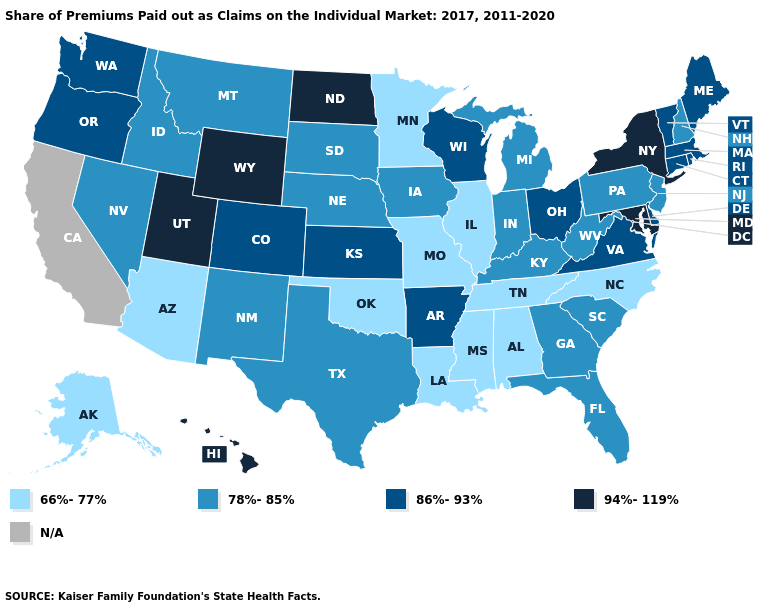Which states have the lowest value in the Northeast?
Concise answer only. New Hampshire, New Jersey, Pennsylvania. What is the value of North Carolina?
Answer briefly. 66%-77%. Does the map have missing data?
Write a very short answer. Yes. What is the highest value in the USA?
Answer briefly. 94%-119%. What is the lowest value in the South?
Write a very short answer. 66%-77%. What is the value of Tennessee?
Short answer required. 66%-77%. Does the map have missing data?
Quick response, please. Yes. What is the lowest value in states that border Texas?
Keep it brief. 66%-77%. What is the highest value in the USA?
Keep it brief. 94%-119%. Does Mississippi have the lowest value in the USA?
Be succinct. Yes. Does Oklahoma have the lowest value in the USA?
Answer briefly. Yes. Does New York have the highest value in the Northeast?
Give a very brief answer. Yes. What is the lowest value in the USA?
Answer briefly. 66%-77%. 